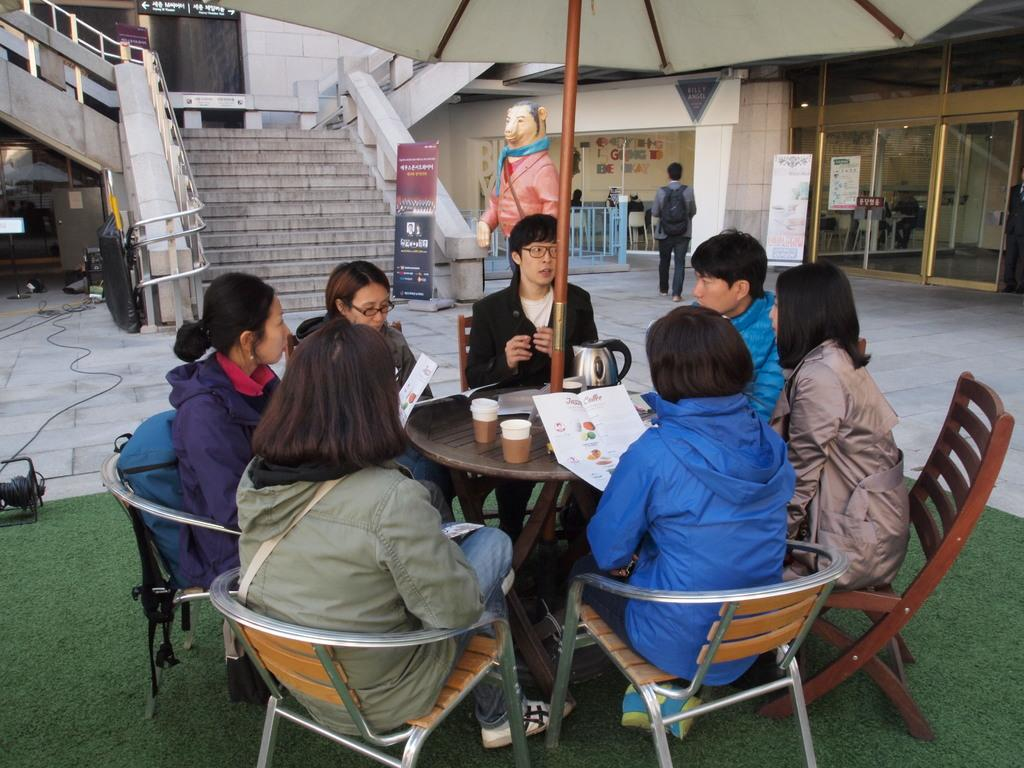What is happening in the image involving the people? There are people around a table, and they are sitting on chairs. Can you describe the setting in which the people are sitting? The people are sitting around a table, which suggests they might be in a dining or meeting area. What is happening in the background of the image? In the background, there is a person wearing a bag and walking on the floor. How many people are visible in the image? There are at least two people visible in the image: the people sitting around the table and the person in the background. What type of wilderness can be seen in the background of the image? There is no wilderness present in the image; it features people sitting around a table and a person walking in the background. What kind of flower is being held by the owner of the table? There is no flower or owner mentioned in the image; it only shows people sitting around a table and a person walking in the background. 